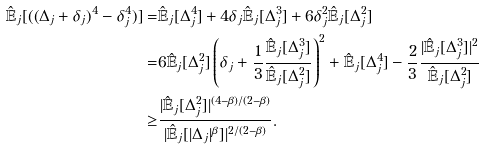Convert formula to latex. <formula><loc_0><loc_0><loc_500><loc_500>\hat { \mathbb { E } } _ { j } [ ( ( \Delta _ { j } + \delta _ { j } ) ^ { 4 } - \delta _ { j } ^ { 4 } ) ] = & \hat { \mathbb { E } } _ { j } [ \Delta _ { j } ^ { 4 } ] + 4 \delta _ { j } \hat { \mathbb { E } } _ { j } [ \Delta _ { j } ^ { 3 } ] + 6 \delta _ { j } ^ { 2 } \hat { \mathbb { E } } _ { j } [ \Delta _ { j } ^ { 2 } ] \\ = & 6 \hat { \mathbb { E } } _ { j } [ \Delta _ { j } ^ { 2 } ] \left ( \delta _ { j } + \frac { 1 } { 3 } \frac { \hat { \mathbb { E } } _ { j } [ \Delta _ { j } ^ { 3 } ] } { \hat { \mathbb { E } } _ { j } [ \Delta _ { j } ^ { 2 } ] } \right ) ^ { 2 } + \hat { \mathbb { E } } _ { j } [ \Delta _ { j } ^ { 4 } ] - \frac { 2 } { 3 } \frac { | \hat { \mathbb { E } } _ { j } [ \Delta _ { j } ^ { 3 } ] | ^ { 2 } } { \hat { \mathbb { E } } _ { j } [ \Delta _ { j } ^ { 2 } ] } \\ \geq & \frac { | \hat { \mathbb { E } } _ { j } [ \Delta _ { j } ^ { 2 } ] | ^ { ( 4 - \beta ) / ( 2 - \beta ) } } { | \hat { \mathbb { E } } _ { j } [ | \Delta _ { j } | ^ { \beta } ] | ^ { 2 / ( 2 - \beta ) } } .</formula> 